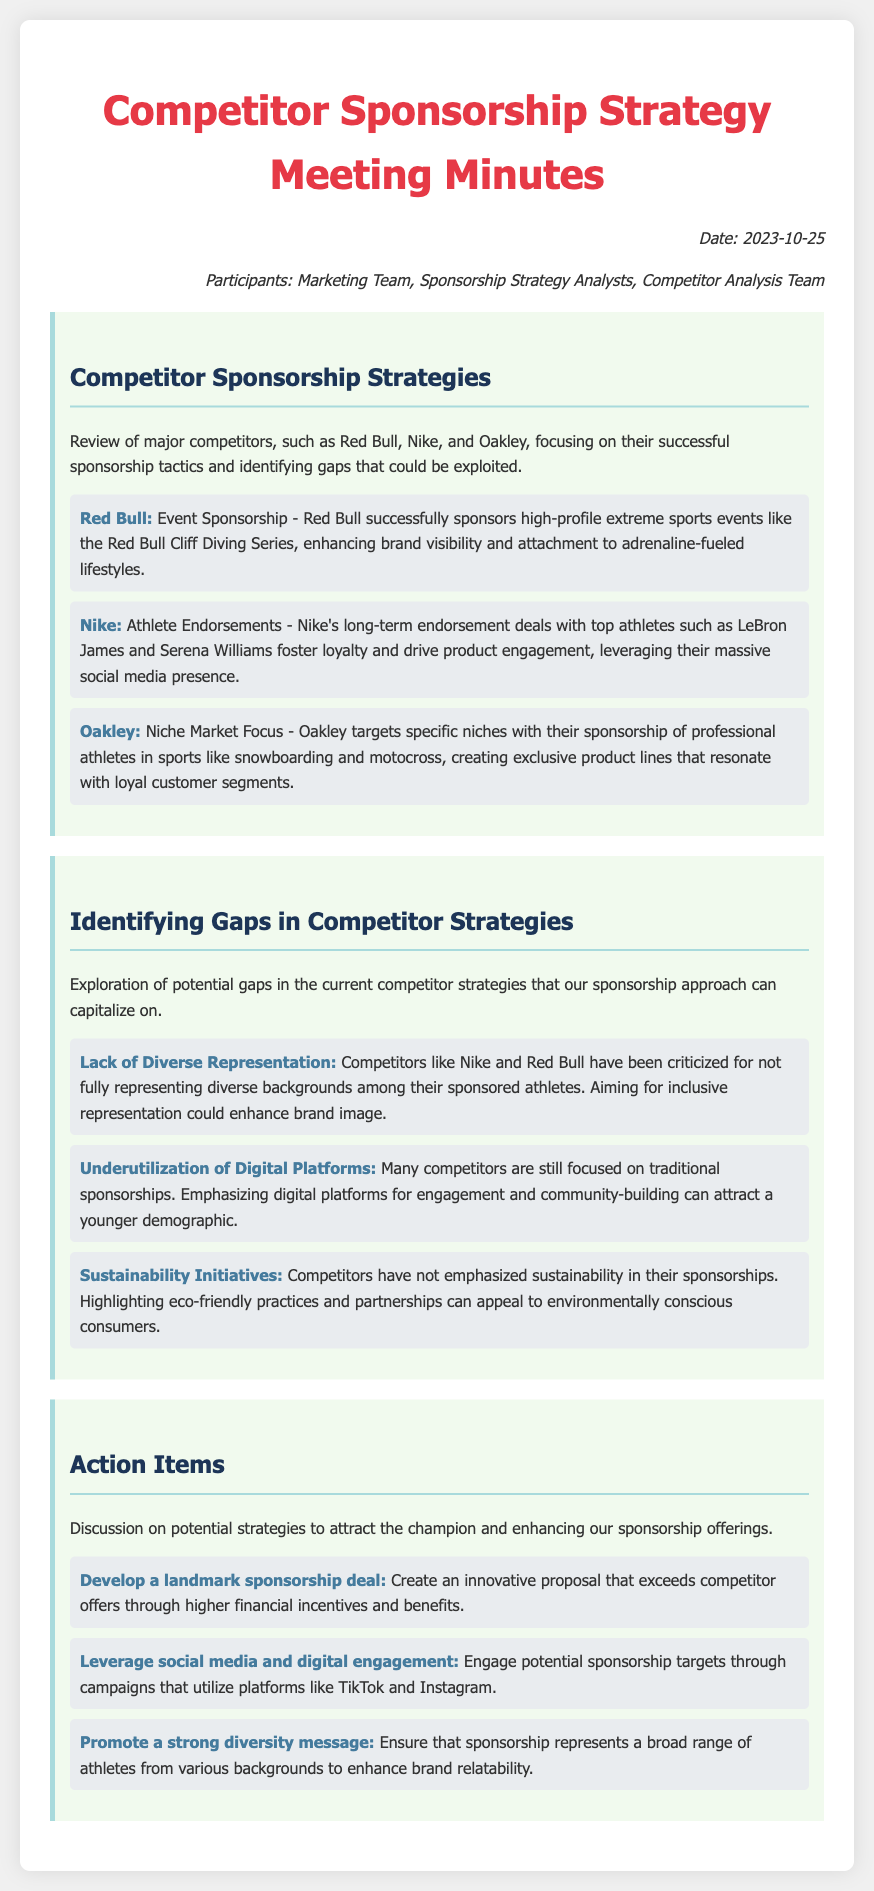What is the date of the meeting? The document states the meeting took place on October 25, 2023.
Answer: October 25, 2023 Who sponsored the high-profile extreme sports events mentioned? Red Bull is noted for sponsoring events like the Red Bull Cliff Diving Series.
Answer: Red Bull What is one of Nike's successful tactics in sponsorship? The document highlights Nike's long-term endorsement deals with top athletes as a key tactic.
Answer: Athlete Endorsements What is a gap identified in competitor strategies? The document mentions a lack of diverse representation as a gap in competitor strategies.
Answer: Lack of Diverse Representation Which digital platforms are suggested for engagement? The action items recommend utilizing platforms like TikTok and Instagram for digital engagement.
Answer: TikTok and Instagram What is one action item proposed to attract the champion? The meeting minutes suggest developing a landmark sponsorship deal to attract the champion.
Answer: Develop a landmark sponsorship deal Which competitor focuses on specific niches with their athlete sponsorships? The document notes that Oakley targets specific niches in sports through their sponsorships.
Answer: Oakley What initiative could appeal to environmentally conscious consumers? Highlighting sustainability initiatives in sponsorships is mentioned as a potential strategy.
Answer: Sustainability Initiatives 